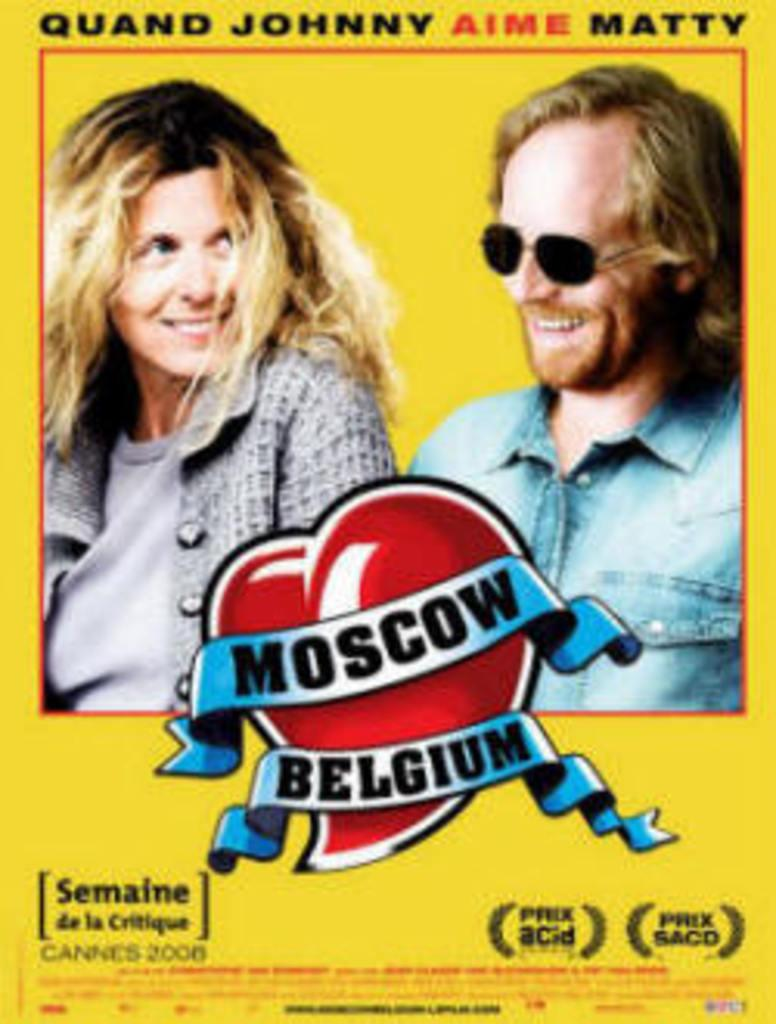What color is the poster in the image? The poster in the image is yellow. What is depicted on the poster? The poster features a man and a woman. What expressions do the man and woman have on the poster? Both the man and the woman are smiling on the poster. What else can be seen on the poster besides the images of the man and woman? There is text written on the poster. How many hens are present on the poster? There are no hens depicted on the poster; it features a man and a woman. What type of support can be seen on the poster? There is no support visible on the poster; it is a flat, two-dimensional image. 